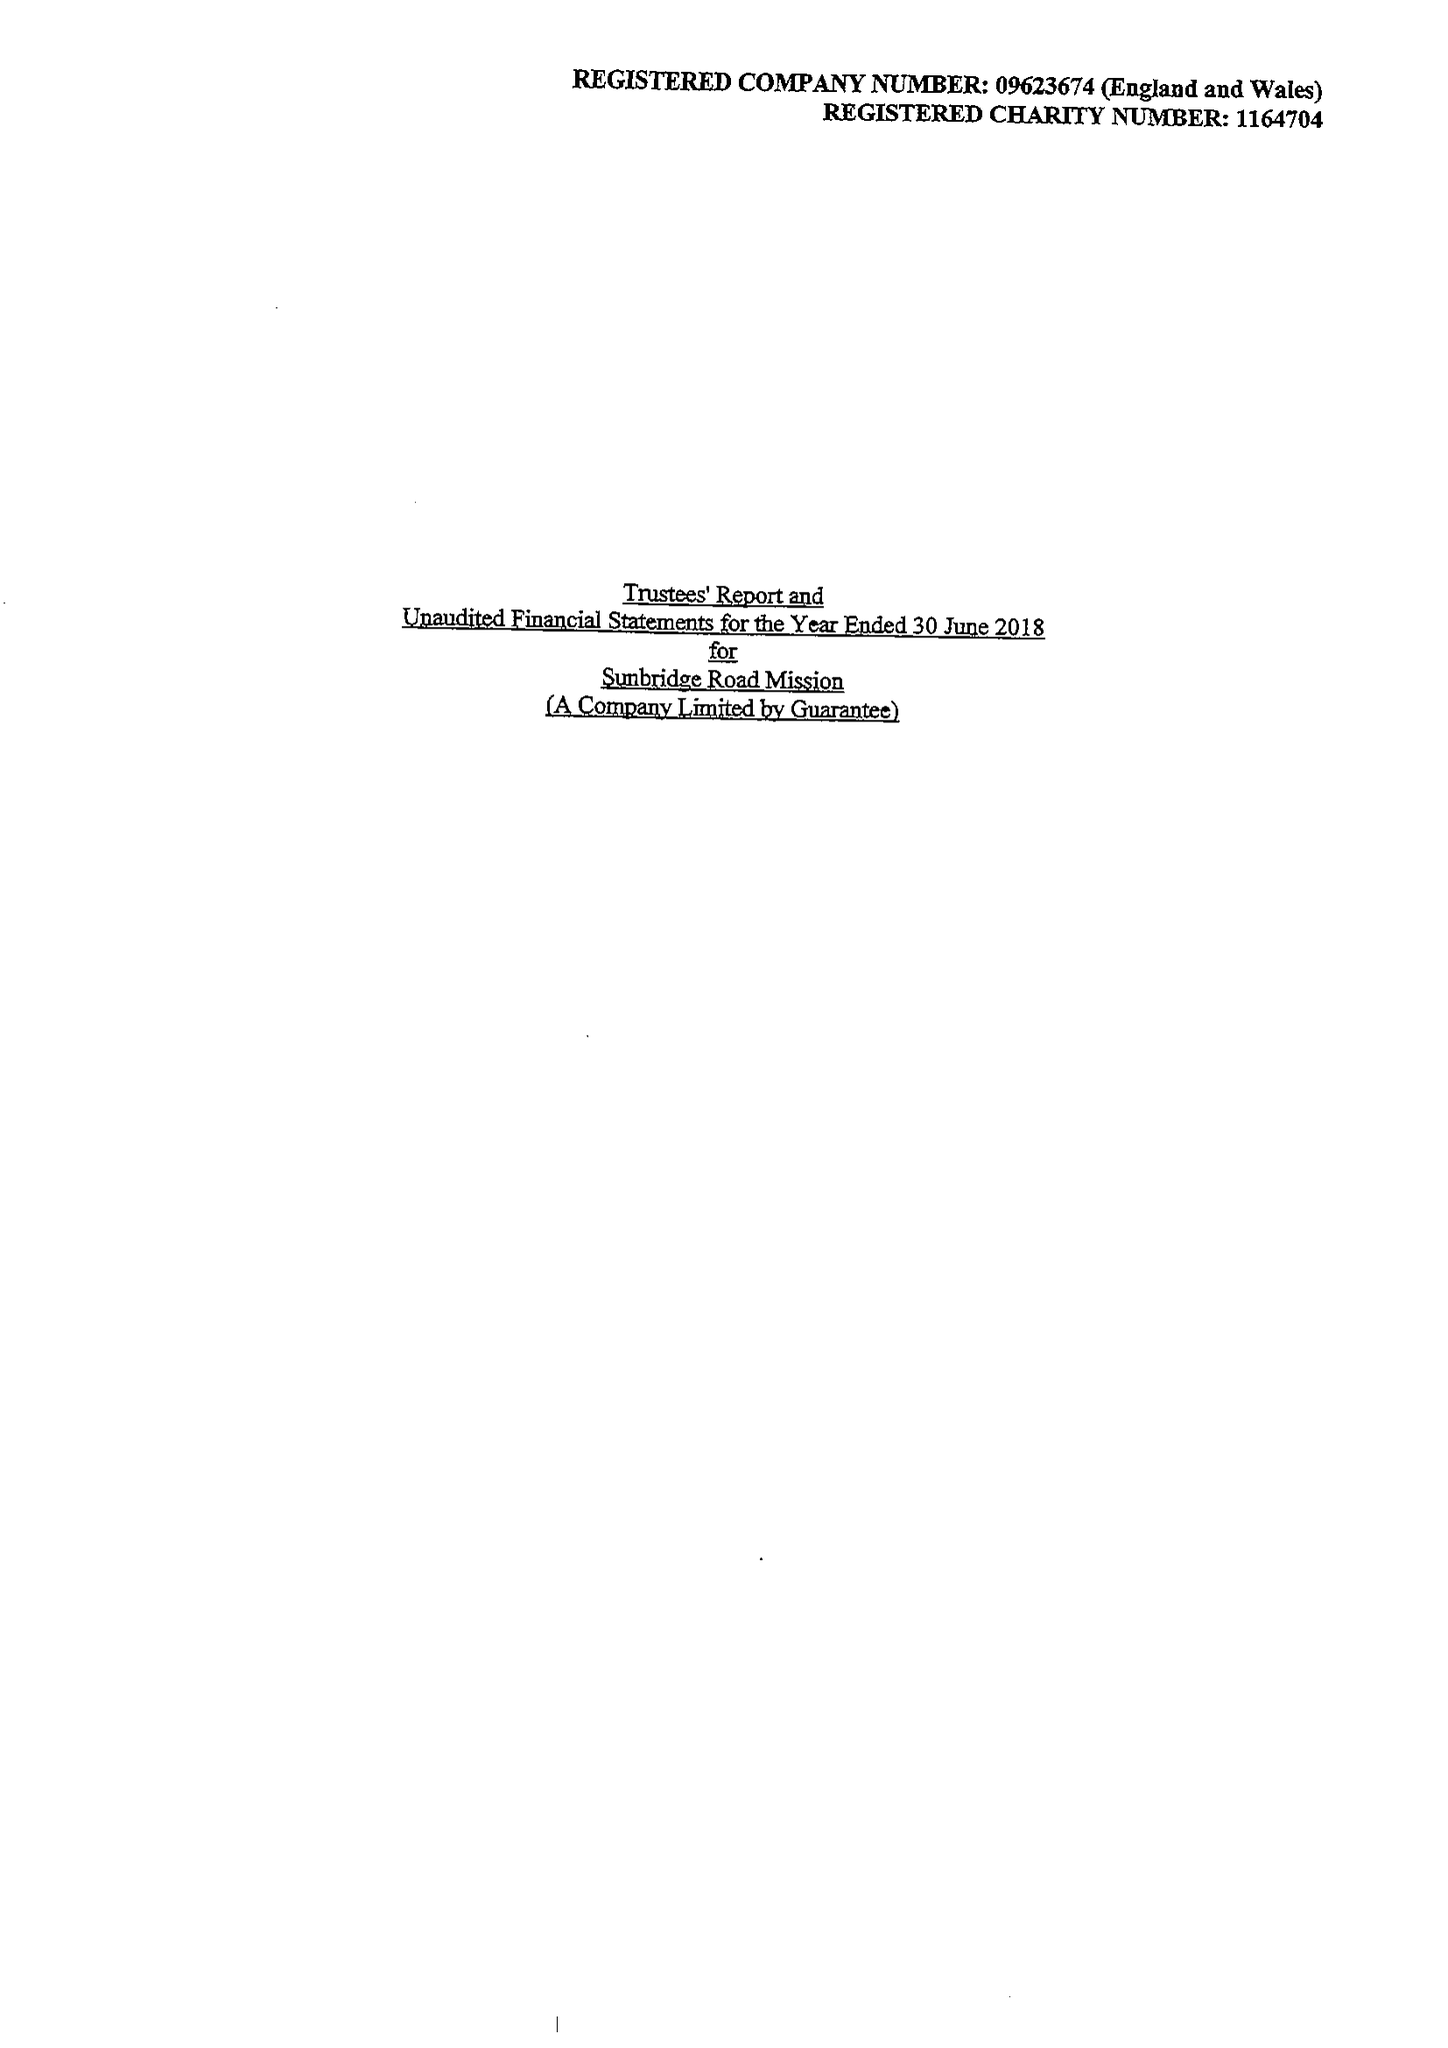What is the value for the address__street_line?
Answer the question using a single word or phrase. 15 MEADOW COURT 